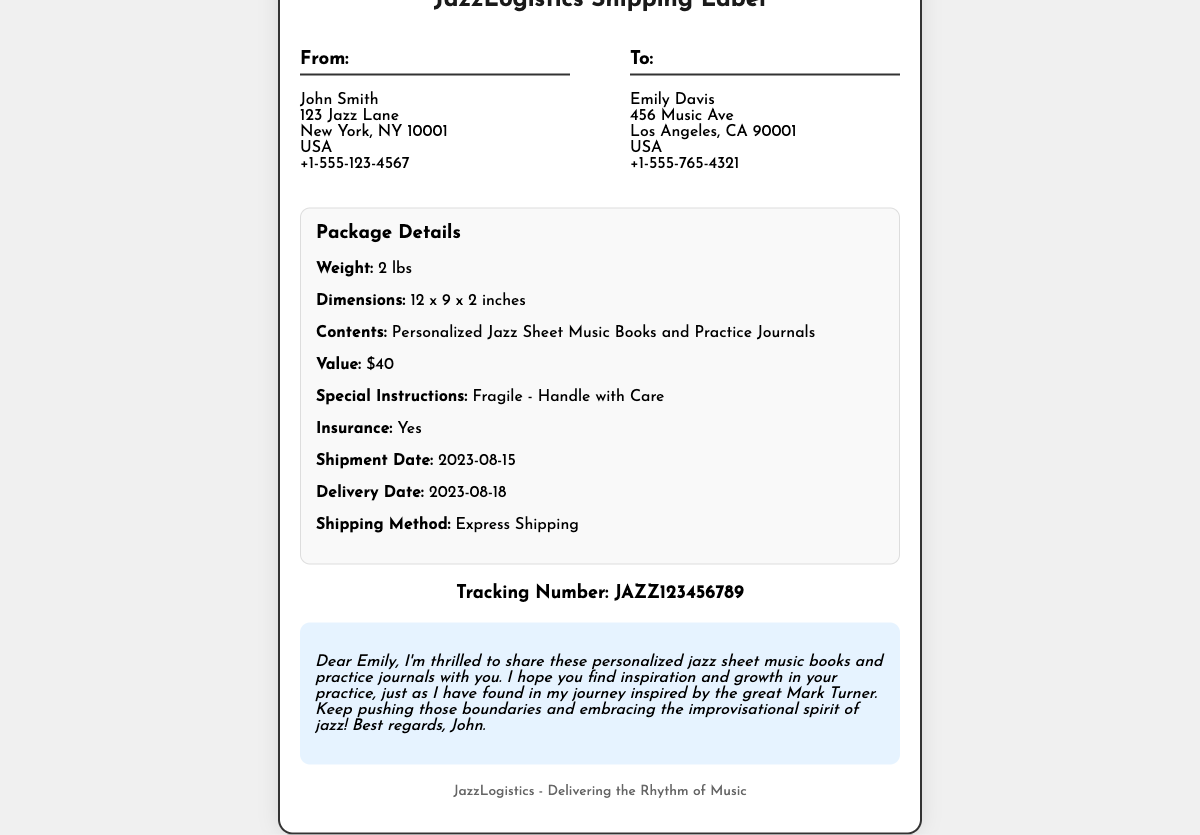What is the sender's name? The sender's name is found in the "From" section of the document, which lists "John Smith."
Answer: John Smith What is the recipient's address? The recipient's full address can be found in the "To" section, which includes the name and the address details.
Answer: 456 Music Ave, Los Angeles, CA 90001, USA What is the weight of the package? The weight of the package is specified in the package details section.
Answer: 2 lbs What is the value of the contents? The value of the contents is listed under package details in the document.
Answer: $40 What is the tracking number? The tracking number is prominently displayed in the tracking info section of the document.
Answer: JAZZ123456789 When was the shipment date? The date when the shipment was sent can be found in the package details section which indicates when it was shipped.
Answer: 2023-08-15 What are the special instructions for handling the package? The handling instructions are included in the package details to ensure proper care.
Answer: Fragile - Handle with Care What is the shipping method used? The shipping method is provided in the package details and indicates how the package is sent.
Answer: Express Shipping What is the sender's note about? The sender's note is a personal message included in the document, expressing thoughts related to the contents.
Answer: Inspiration and growth in practice 